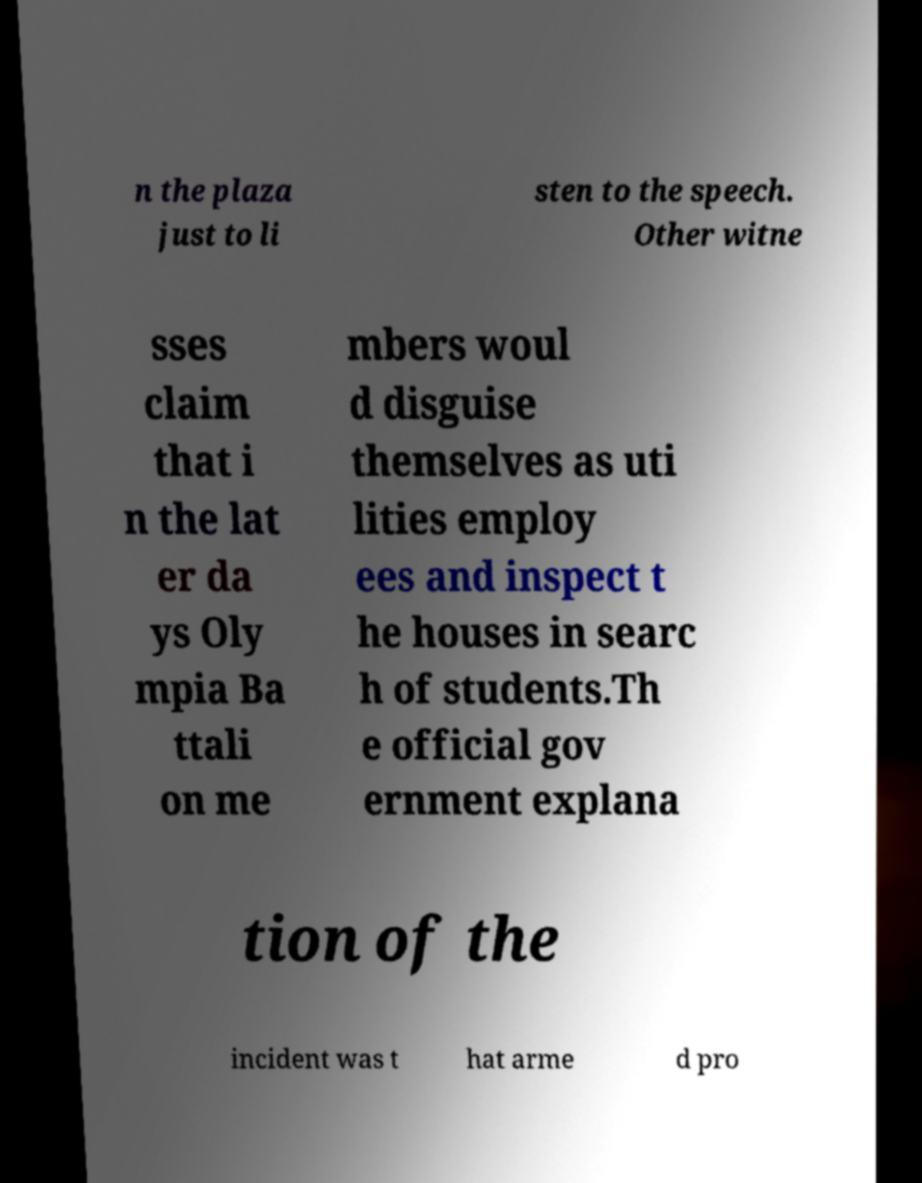I need the written content from this picture converted into text. Can you do that? n the plaza just to li sten to the speech. Other witne sses claim that i n the lat er da ys Oly mpia Ba ttali on me mbers woul d disguise themselves as uti lities employ ees and inspect t he houses in searc h of students.Th e official gov ernment explana tion of the incident was t hat arme d pro 